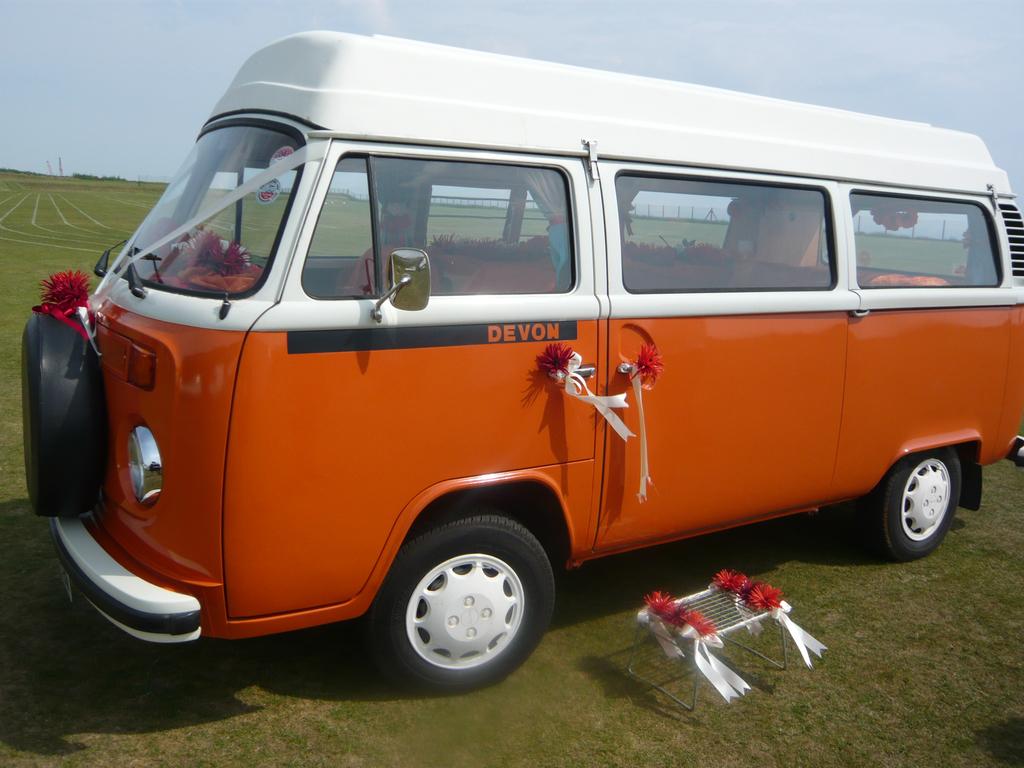What company owns the truck on the left?
Offer a very short reply. Devon. Is this a devon van?
Offer a terse response. Yes. 